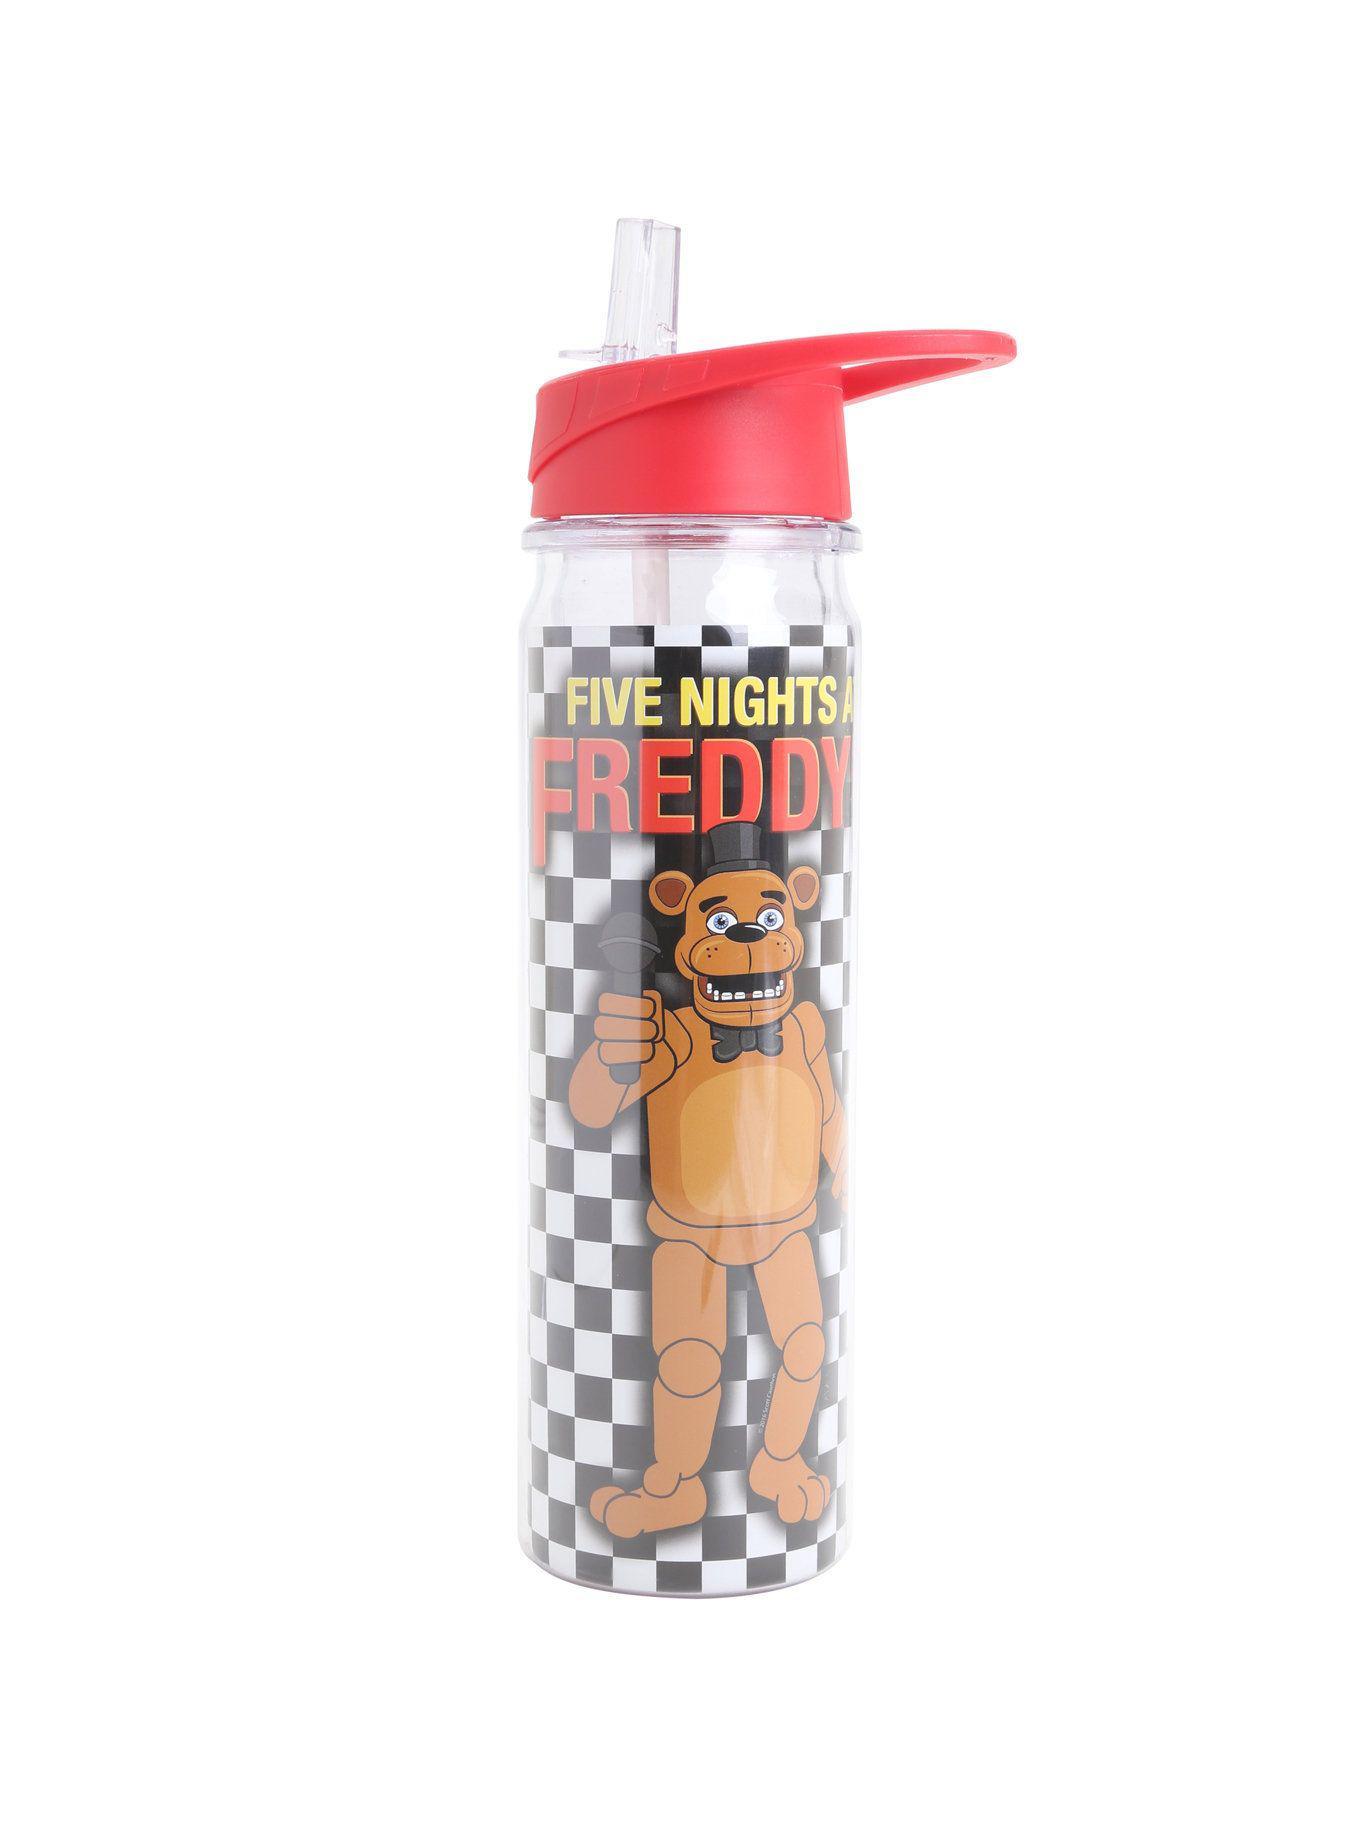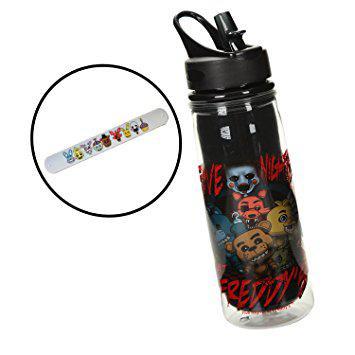The first image is the image on the left, the second image is the image on the right. For the images shown, is this caption "Both images contain one mostly black reusable water bottle." true? Answer yes or no. No. The first image is the image on the left, the second image is the image on the right. Considering the images on both sides, is "The left and right image contains a total of two black bottles." valid? Answer yes or no. No. 